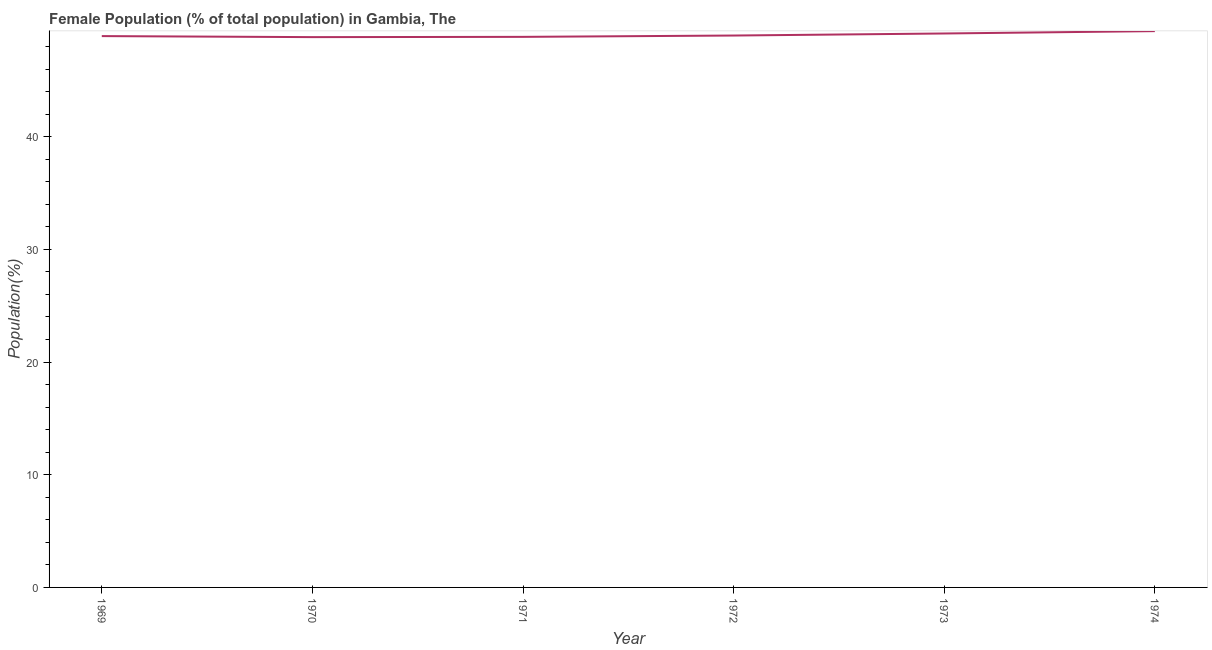What is the female population in 1971?
Your response must be concise. 48.85. Across all years, what is the maximum female population?
Give a very brief answer. 49.36. Across all years, what is the minimum female population?
Give a very brief answer. 48.83. In which year was the female population maximum?
Provide a succinct answer. 1974. In which year was the female population minimum?
Give a very brief answer. 1970. What is the sum of the female population?
Ensure brevity in your answer.  294.09. What is the difference between the female population in 1970 and 1972?
Ensure brevity in your answer.  -0.14. What is the average female population per year?
Provide a short and direct response. 49.01. What is the median female population?
Offer a very short reply. 48.95. In how many years, is the female population greater than 36 %?
Your response must be concise. 6. What is the ratio of the female population in 1969 to that in 1971?
Keep it short and to the point. 1. Is the female population in 1969 less than that in 1971?
Provide a succinct answer. No. What is the difference between the highest and the second highest female population?
Your answer should be compact. 0.21. Is the sum of the female population in 1969 and 1974 greater than the maximum female population across all years?
Offer a terse response. Yes. What is the difference between the highest and the lowest female population?
Keep it short and to the point. 0.53. In how many years, is the female population greater than the average female population taken over all years?
Your answer should be compact. 2. Does the female population monotonically increase over the years?
Your response must be concise. No. How many lines are there?
Keep it short and to the point. 1. How many years are there in the graph?
Ensure brevity in your answer.  6. Does the graph contain any zero values?
Offer a very short reply. No. Does the graph contain grids?
Your answer should be compact. No. What is the title of the graph?
Offer a very short reply. Female Population (% of total population) in Gambia, The. What is the label or title of the Y-axis?
Your answer should be very brief. Population(%). What is the Population(%) of 1969?
Keep it short and to the point. 48.92. What is the Population(%) in 1970?
Your answer should be very brief. 48.83. What is the Population(%) of 1971?
Provide a succinct answer. 48.85. What is the Population(%) in 1972?
Ensure brevity in your answer.  48.97. What is the Population(%) in 1973?
Your answer should be compact. 49.15. What is the Population(%) in 1974?
Your response must be concise. 49.36. What is the difference between the Population(%) in 1969 and 1970?
Provide a succinct answer. 0.09. What is the difference between the Population(%) in 1969 and 1971?
Your answer should be very brief. 0.07. What is the difference between the Population(%) in 1969 and 1972?
Offer a terse response. -0.05. What is the difference between the Population(%) in 1969 and 1973?
Offer a terse response. -0.23. What is the difference between the Population(%) in 1969 and 1974?
Keep it short and to the point. -0.44. What is the difference between the Population(%) in 1970 and 1971?
Keep it short and to the point. -0.02. What is the difference between the Population(%) in 1970 and 1972?
Your answer should be very brief. -0.14. What is the difference between the Population(%) in 1970 and 1973?
Your answer should be compact. -0.32. What is the difference between the Population(%) in 1970 and 1974?
Offer a very short reply. -0.53. What is the difference between the Population(%) in 1971 and 1972?
Offer a very short reply. -0.12. What is the difference between the Population(%) in 1971 and 1973?
Offer a very short reply. -0.3. What is the difference between the Population(%) in 1971 and 1974?
Provide a short and direct response. -0.51. What is the difference between the Population(%) in 1972 and 1973?
Your response must be concise. -0.18. What is the difference between the Population(%) in 1972 and 1974?
Your answer should be very brief. -0.39. What is the difference between the Population(%) in 1973 and 1974?
Give a very brief answer. -0.21. What is the ratio of the Population(%) in 1969 to that in 1972?
Ensure brevity in your answer.  1. What is the ratio of the Population(%) in 1969 to that in 1973?
Provide a succinct answer. 0.99. What is the ratio of the Population(%) in 1970 to that in 1972?
Make the answer very short. 1. What is the ratio of the Population(%) in 1970 to that in 1973?
Give a very brief answer. 0.99. What is the ratio of the Population(%) in 1970 to that in 1974?
Ensure brevity in your answer.  0.99. 